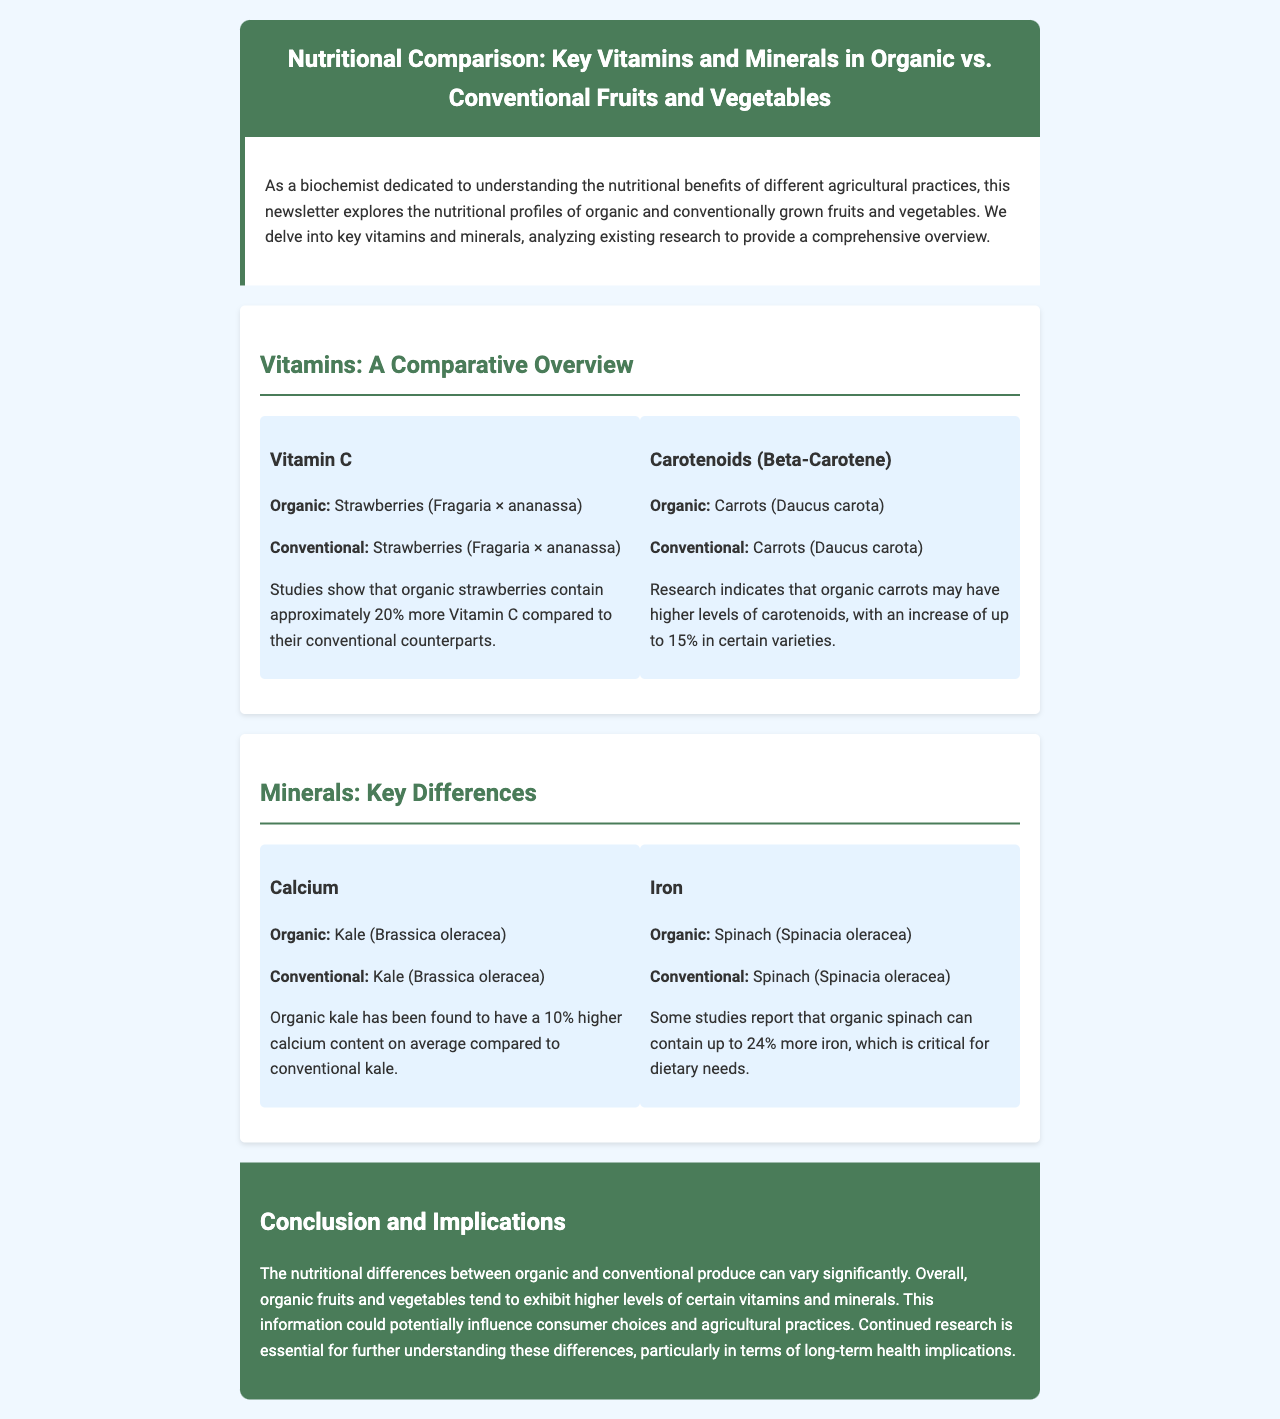What vitamin content is higher in organic strawberries? The document states that organic strawberries contain approximately 20% more Vitamin C compared to conventional strawberries.
Answer: Vitamin C Which mineral is reported to be 10% higher in organic kale? According to the document, organic kale has been found to have a 10% higher calcium content on average compared to conventional kale.
Answer: Calcium What fruit contains more iron when grown organically? The document mentions that organic spinach can contain up to 24% more iron.
Answer: Spinach How much more carotenoids can organic carrots have? The document indicates that organic carrots may have higher levels of carotenoids, with an increase of up to 15% in certain varieties.
Answer: 15% What is the main focus of the newsletter? The introduction of the document explains that the newsletter explores the nutritional profiles of organic and conventionally grown fruits and vegetables, focusing on key vitamins and minerals.
Answer: Nutritional profiles Which section discusses the comparison of vitamins? The document contains a section titled "Vitamins: A Comparative Overview," which focuses on comparing vitamins in organic and conventional produce.
Answer: Vitamins: A Comparative Overview What key nutrient in organic spinach is highlighted? The document highlights that organic spinach can contain more iron, which is critical for dietary needs.
Answer: Iron What is the conclusion about the nutritional differences between organic and conventional produce? The conclusion summarizes that organic fruits and vegetables tend to exhibit higher levels of certain vitamins and minerals.
Answer: Higher levels of vitamins and minerals 